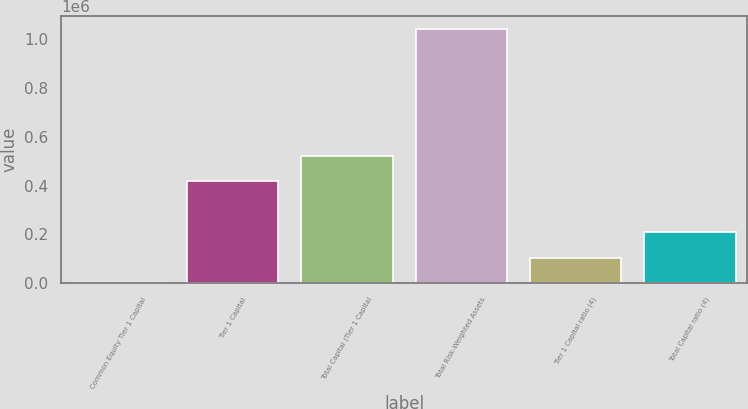Convert chart. <chart><loc_0><loc_0><loc_500><loc_500><bar_chart><fcel>Common Equity Tier 1 Capital<fcel>Tier 1 Capital<fcel>Total Capital (Tier 1 Capital<fcel>Total Risk-Weighted Assets<fcel>Tier 1 Capital ratio (4)<fcel>Total Capital ratio (4)<nl><fcel>12.28<fcel>417915<fcel>522390<fcel>1.04477e+06<fcel>104488<fcel>208963<nl></chart> 